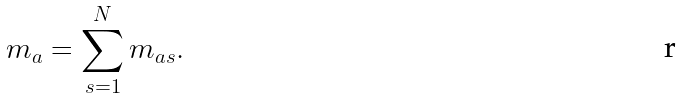<formula> <loc_0><loc_0><loc_500><loc_500>m _ { a } = \sum _ { s = 1 } ^ { N } m _ { a s } .</formula> 